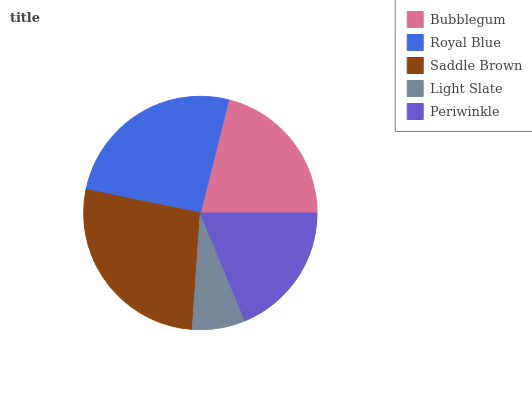Is Light Slate the minimum?
Answer yes or no. Yes. Is Saddle Brown the maximum?
Answer yes or no. Yes. Is Royal Blue the minimum?
Answer yes or no. No. Is Royal Blue the maximum?
Answer yes or no. No. Is Royal Blue greater than Bubblegum?
Answer yes or no. Yes. Is Bubblegum less than Royal Blue?
Answer yes or no. Yes. Is Bubblegum greater than Royal Blue?
Answer yes or no. No. Is Royal Blue less than Bubblegum?
Answer yes or no. No. Is Bubblegum the high median?
Answer yes or no. Yes. Is Bubblegum the low median?
Answer yes or no. Yes. Is Light Slate the high median?
Answer yes or no. No. Is Saddle Brown the low median?
Answer yes or no. No. 